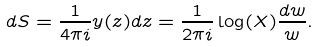Convert formula to latex. <formula><loc_0><loc_0><loc_500><loc_500>d S = \frac { 1 } { 4 \pi i } y ( z ) d z = \frac { 1 } { 2 \pi i } \log ( X ) \frac { d w } { w } .</formula> 